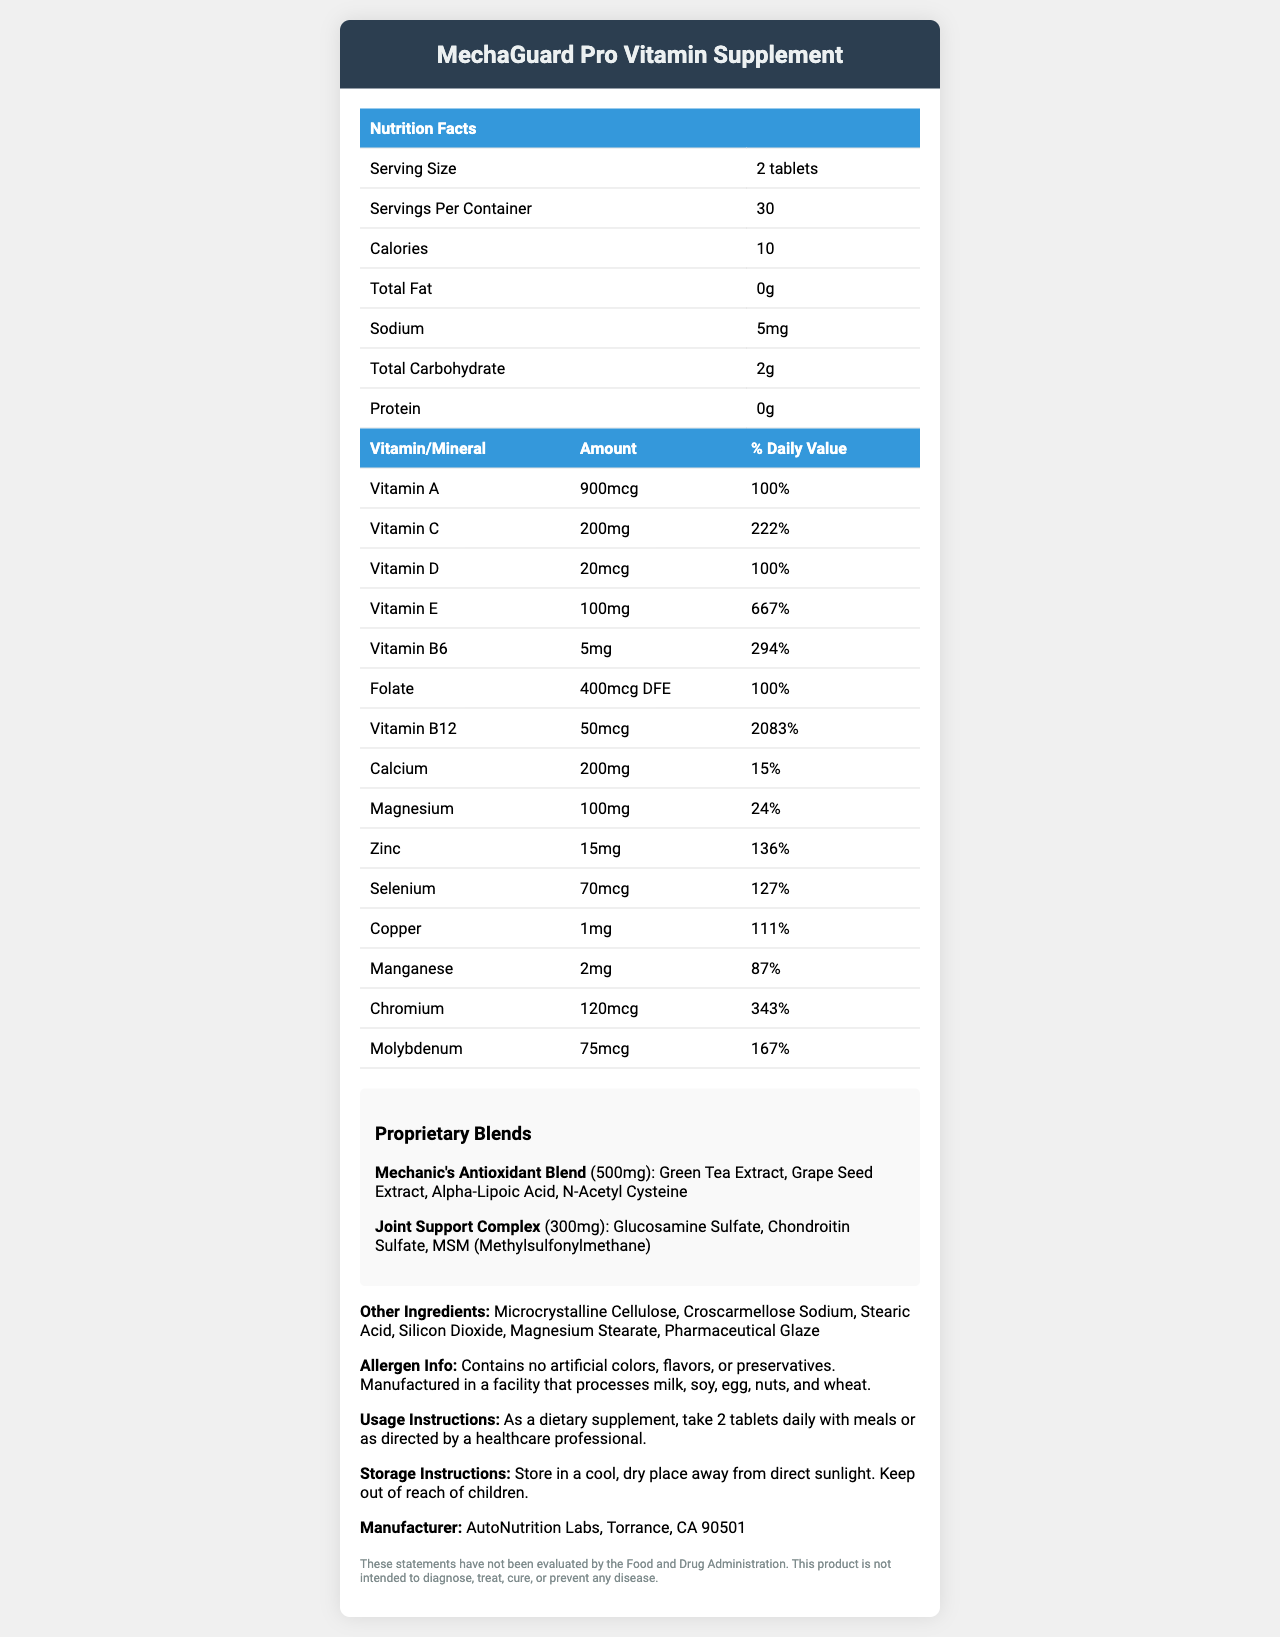what is the serving size of MechaGuard Pro Vitamin Supplement? The document lists the serving size as "2 tablets".
Answer: 2 tablets how many servings are there per container? The document states there are 30 servings per container.
Answer: 30 what is the total amount of calories in a serving? The document lists the calories per serving as 10.
Answer: 10 how much Vitamin C is in one serving? The document indicates that each serving contains 200mg of Vitamin C, which is 222% of the daily value.
Answer: 200mg how much Zinc does one serving contain? According to the document, one serving contains 15mg of Zinc, which is 136% of the daily value.
Answer: 15mg which vitamin has the highest % daily value among listed vitamins? A. Vitamin A B. Vitamin D C. Vitamin B12 The document lists Vitamin B12 with a daily value of 2083%, which is the highest among the listed vitamins.
Answer: C how much of Mechanic's Antioxidant Blend is in each serving? A. 100mg B. 300mg C. 500mg D. 200mg The document specifies that Mechanic's Antioxidant Blend is 500mg per serving.
Answer: C which of the following ingredients is NOT part of the Joint Support Complex? A. Glucosamine Sulfate B. Chondroitin Sulfate C. Alpha-Lipoic Acid D. MSM (Methylsulfonylmethane) The document lists "Glucosamine Sulfate", "Chondroitin Sulfate", and "MSM" as part of the Joint Support Complex, but "Alpha-Lipoic Acid" is part of the Mechanic's Antioxidant Blend.
Answer: C does the product contain any artificial colors? The document states that the product contains no artificial colors, flavors, or preservatives.
Answer: No is there any information about the product's manufacturer? The document provides the manufacturer's name and location: AutoNutrition Labs, Torrance, CA 90501.
Answer: Yes summarize the main idea of the document. The document outlines the composition and recommended usage of the MechaGuard Pro Vitamin Supplement, highlighting its benefits for mechanics through specific vitamins, minerals, and proprietary blends.
Answer: The document provides detailed nutritional information for the MechaGuard Pro Vitamin Supplement, including serving size, vitamins and minerals, proprietary blends, other ingredients, usage instructions, allergen information, and manufacturer details. can you find information about the price of the product? The document does not provide any information regarding the price of the MechaGuard Pro Vitamin Supplement.
Answer: Not enough information 